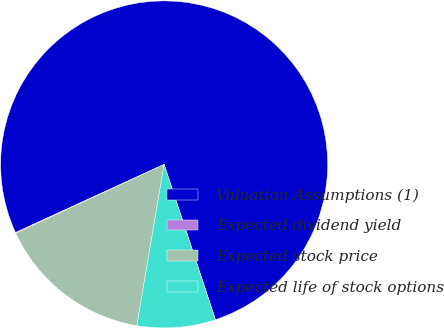<chart> <loc_0><loc_0><loc_500><loc_500><pie_chart><fcel>Valuation Assumptions (1)<fcel>Expected dividend yield<fcel>Expected stock price<fcel>Expected life of stock options<nl><fcel>76.76%<fcel>0.08%<fcel>15.41%<fcel>7.75%<nl></chart> 